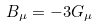Convert formula to latex. <formula><loc_0><loc_0><loc_500><loc_500>B _ { \mu } = - 3 G _ { \mu }</formula> 